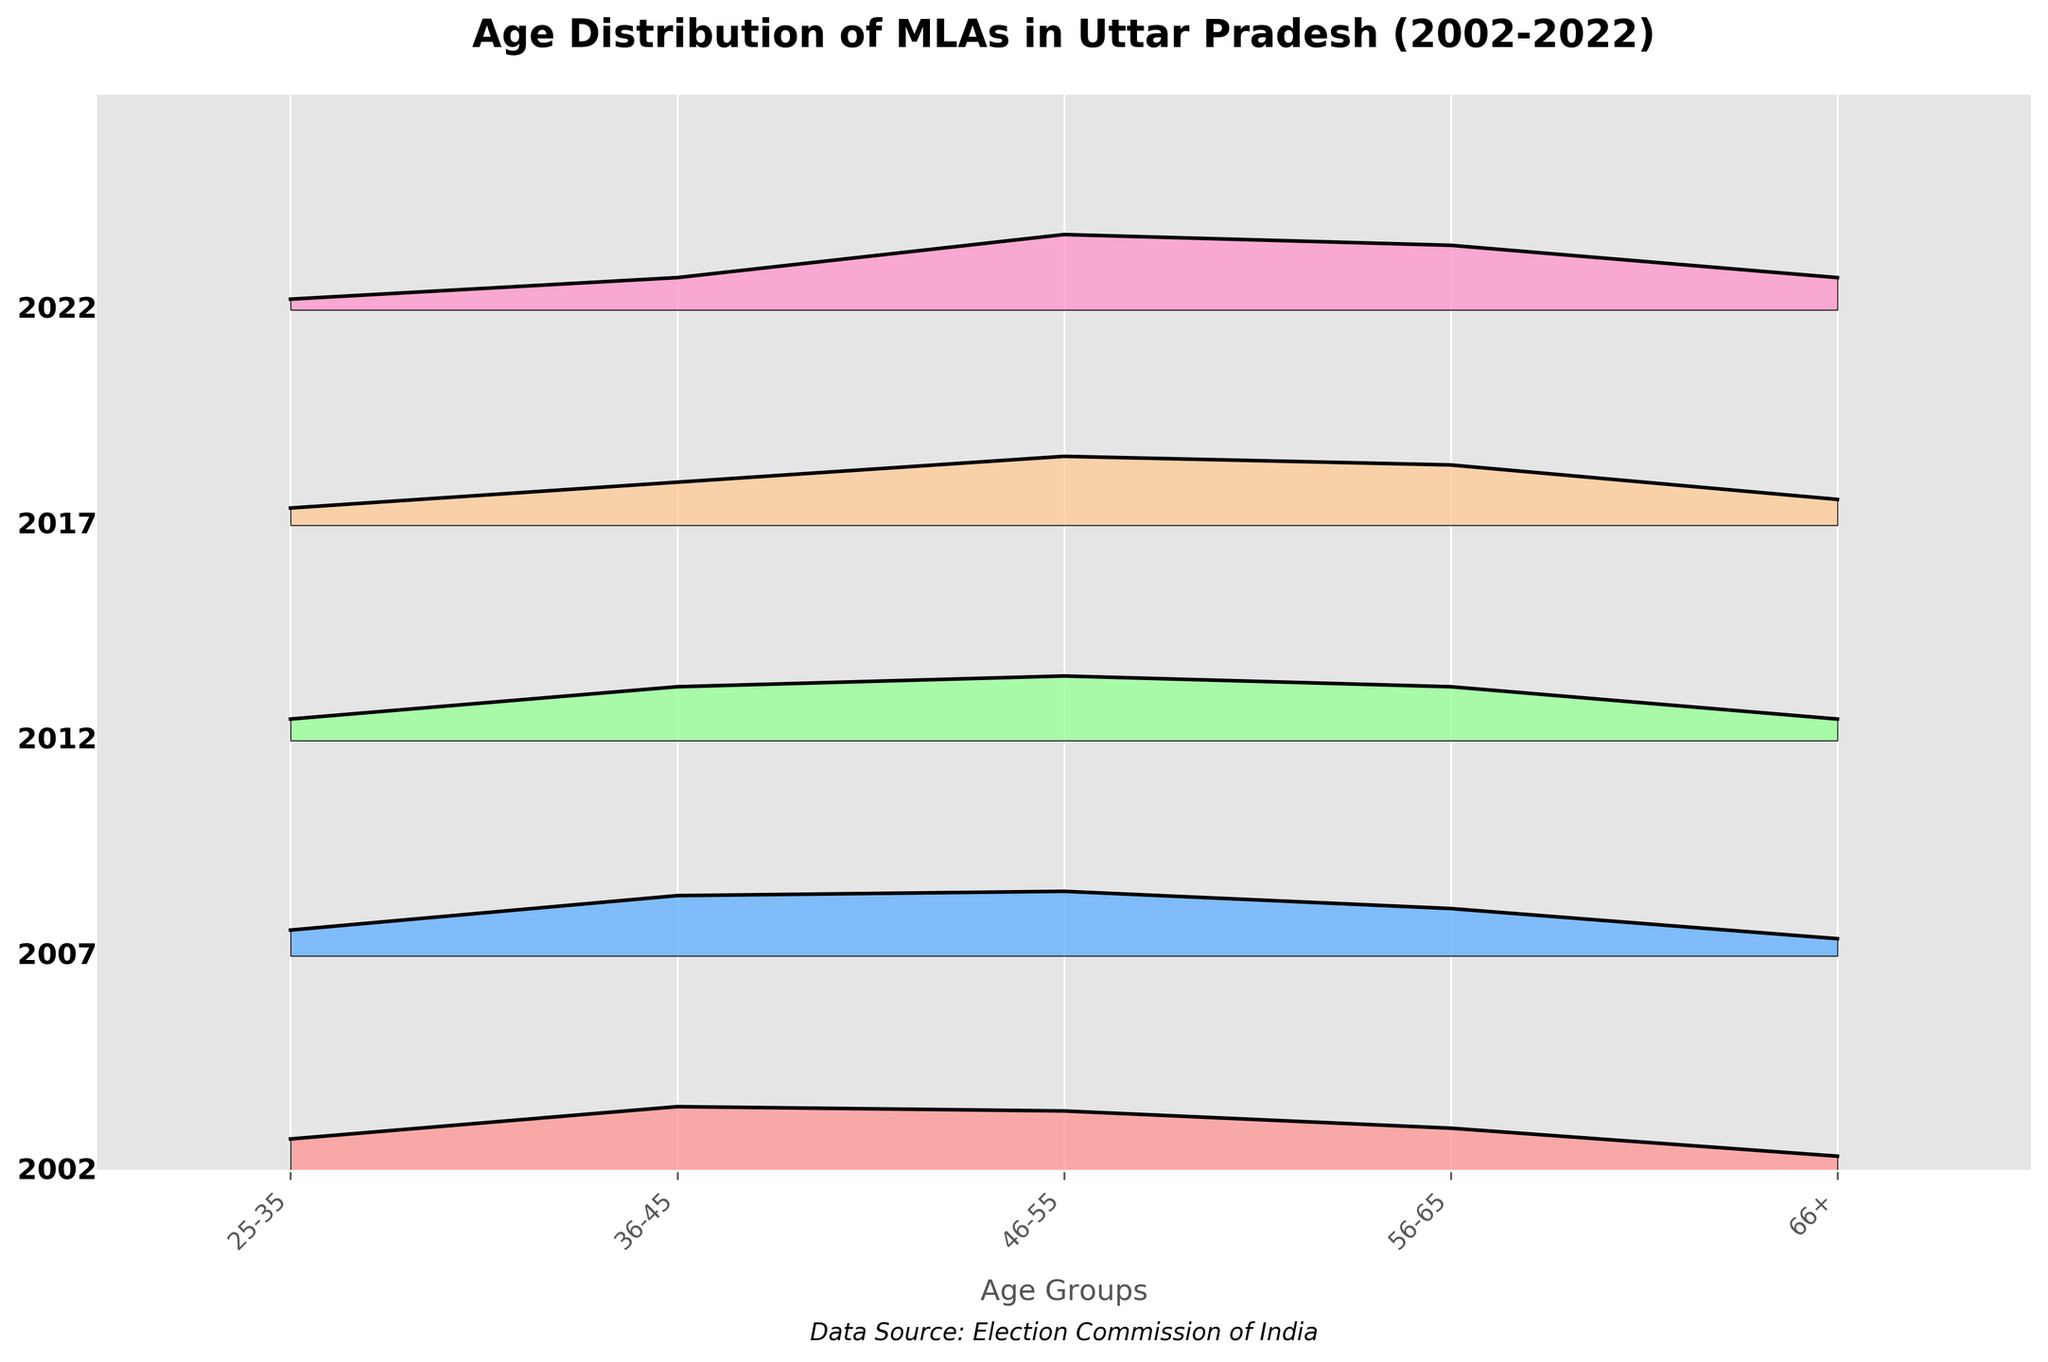What is the main title of the figure? The main title of the figure is typically found at the top and indicates the subject of the plot. In this case, it is "Age Distribution of MLAs in Uttar Pradesh (2002-2022)" as per the code provided.
Answer: Age Distribution of MLAs in Uttar Pradesh (2002-2022) Which age group had the highest density in the 2022 election year? To find the age group with the highest density for 2022, look at the plot area corresponding to 2022 and identify the age group that reaches the highest point on the y-axis. For 2022, "46-55" has the highest density (0.35).
Answer: 46-55 How did the density of the '56-65' age group change from 2002 to 2022? To observe the change in density, compare the values for the '56-65' age group in 2002 (0.20) and in 2022 (0.30). The density increased by 0.10.
Answer: Increased by 0.10 Which election year had the smallest density in the '66+' age group? Examine the plotted densities for the '66+' age group across all years. The smallest value appears for 2002 (0.07).
Answer: 2002 How many election years are included in this figure? Count the number of unique election years noted down the y-axis or in the data set. There are five unique election years (2022, 2017, 2012, 2007, 2002).
Answer: Five Did any age group have a decreasing trend in density from 2002 to 2022? Compare the densities for each age group across the years 2002 to 2022. The age group '25-35' shows a decreasing trend, from 0.15 in 2002 to 0.05 in 2022.
Answer: Yes, '25-35' Which age group consistently had the highest density over the years? To find this, look across all years and find the age group which consistently has the highest peaks. '46-55' often appears to be the highest or among the highest in each year.
Answer: '46-55' Is there any election year where the density of each age group was evenly distributed? Look for an election year where the density values of the age groups are similar. It seems there isn't a year with completely even distribution, but 2012 has relatively closer values among the groups compared to other years.
Answer: No, but 2012 is relatively closer What is the range of densities for the '36-45' age group from 2002 to 2022? Identify the minimum and maximum densities for the '36-45' age group across the years, which are 0.15 (2022) and 0.30 (2002). The range is calculated as the difference between these values, 0.30 - 0.15 = 0.15.
Answer: 0.15 